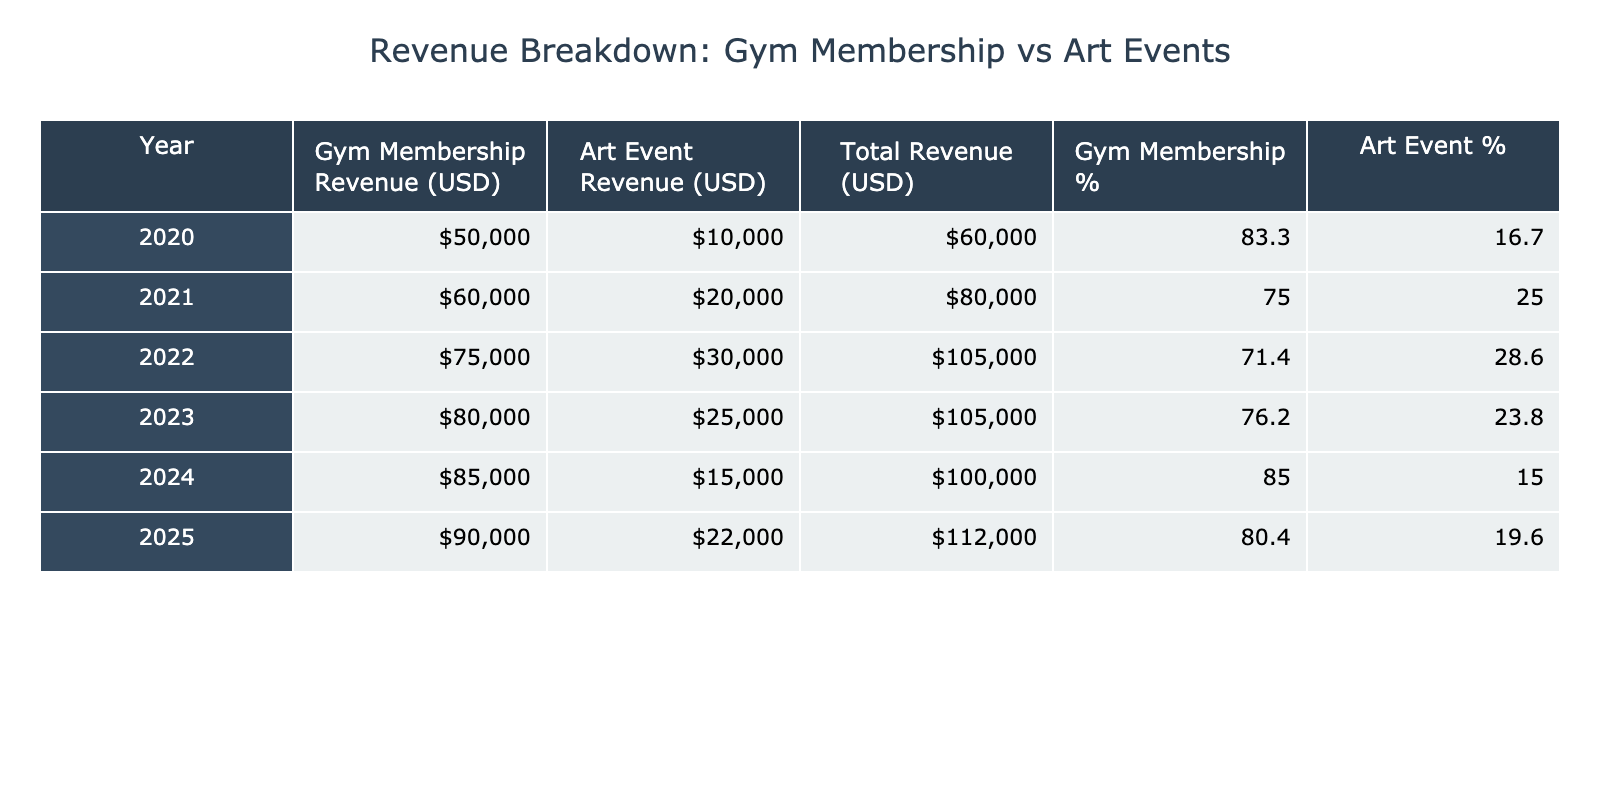What was the total revenue in 2022? To find the total revenue for 2022, we sum the gym membership revenue of 75000 and the art event revenue of 30000: 75000 + 30000 = 105000.
Answer: 105000 What percentage of total revenue came from gym memberships in 2023? For 2023, the total revenue is 80000 (gym) + 25000 (art) = 105000. The percentage from gym memberships is thus (80000 / 105000) * 100 = 76.2%.
Answer: 76.2% Did art event revenue increase every year from 2020 to 2022? Art event revenue for 2020 was 10000, for 2021 it was 20000, and for 2022 it was 30000. Since the revenue increased every year, the statement is true.
Answer: Yes What was the difference in revenue from gym memberships between 2020 and 2025? The revenue from gym memberships in 2020 was 50000 and in 2025 it was 90000. The difference is 90000 - 50000 = 40000.
Answer: 40000 What was the average art event revenue over the years provided? To calculate the average, we sum the art event revenues from each year: 10000 + 20000 + 30000 + 25000 + 15000 + 22000 = 122000. There are 6 years, so the average is 122000 / 6 = 20333.3.
Answer: 20333.3 In which year was gym membership revenue the highest? The gym membership revenue peaked in 2025 at 90000, as no other year has a higher value.
Answer: 2025 Is it true that in 2024 the art event revenue was less than in any previous year? In 2024, art event revenue was 15000. In previous years, the revenues were 10000 (2020), 20000 (2021), 30000 (2022), and 25000 (2023), which means 15000 is less than all these amounts. Hence, the statement is true.
Answer: Yes What was the total amount generated from both revenues in 2021? The total revenue for 2021 is the sum of gym membership revenue of 60000 and art event revenue of 20000: 60000 + 20000 = 80000.
Answer: 80000 How much revenue did you generate from art events in 2025 compared to 2021? The art event revenue in 2021 was 20000, while it was 22000 in 2025. Therefore, we find the difference: 22000 - 20000 = 2000, indicating an increase.
Answer: 2000 